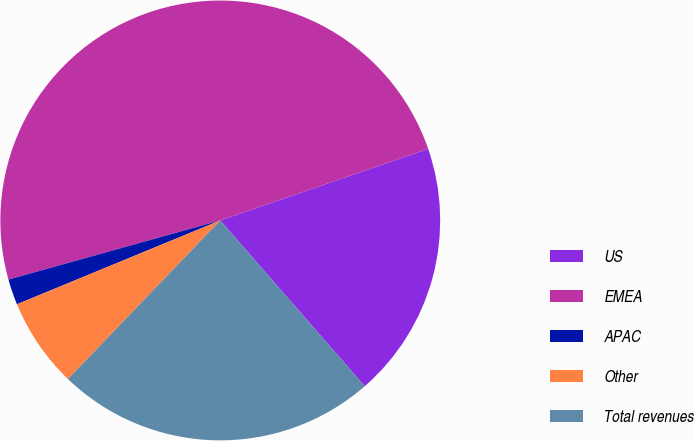Convert chart to OTSL. <chart><loc_0><loc_0><loc_500><loc_500><pie_chart><fcel>US<fcel>EMEA<fcel>APAC<fcel>Other<fcel>Total revenues<nl><fcel>18.87%<fcel>49.06%<fcel>1.89%<fcel>6.6%<fcel>23.58%<nl></chart> 